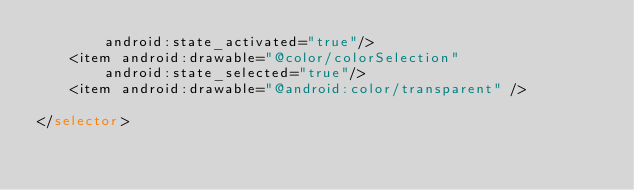Convert code to text. <code><loc_0><loc_0><loc_500><loc_500><_XML_>        android:state_activated="true"/>
    <item android:drawable="@color/colorSelection"
        android:state_selected="true"/>
    <item android:drawable="@android:color/transparent" />

</selector></code> 